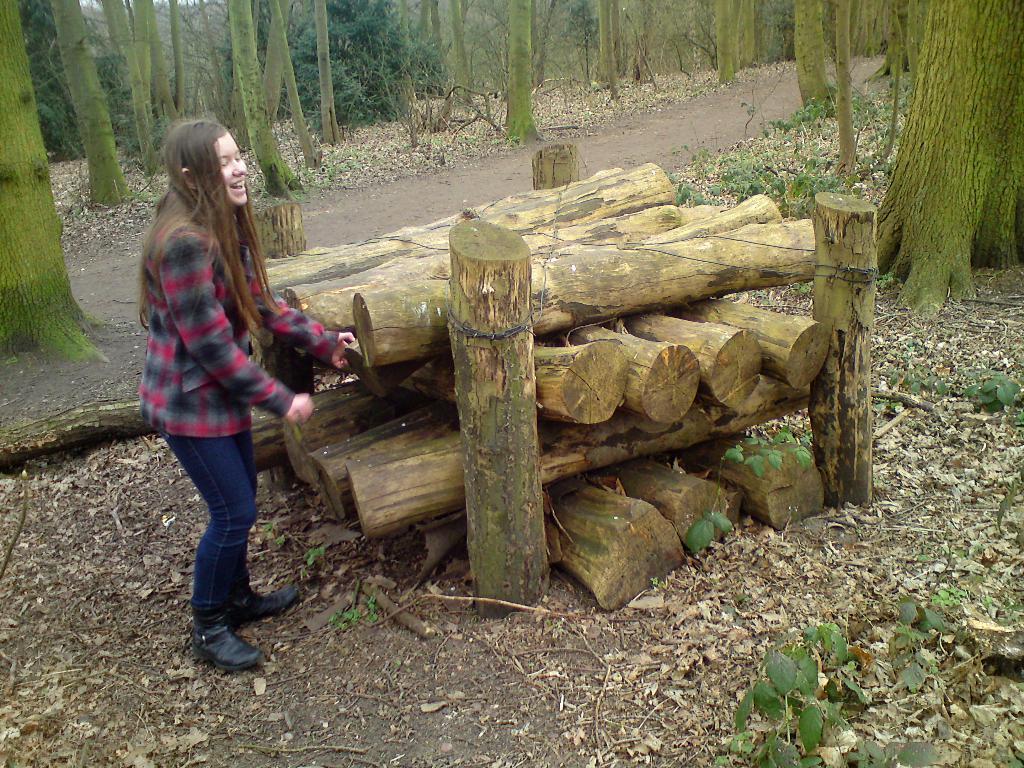Describe this image in one or two sentences. In this image I see a girl who is standing and I see that she is smiling and I see log of woods over here and I see the path on which there are dry leaves and I see number of trees and small plants. 